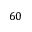Convert formula to latex. <formula><loc_0><loc_0><loc_500><loc_500>6 0</formula> 